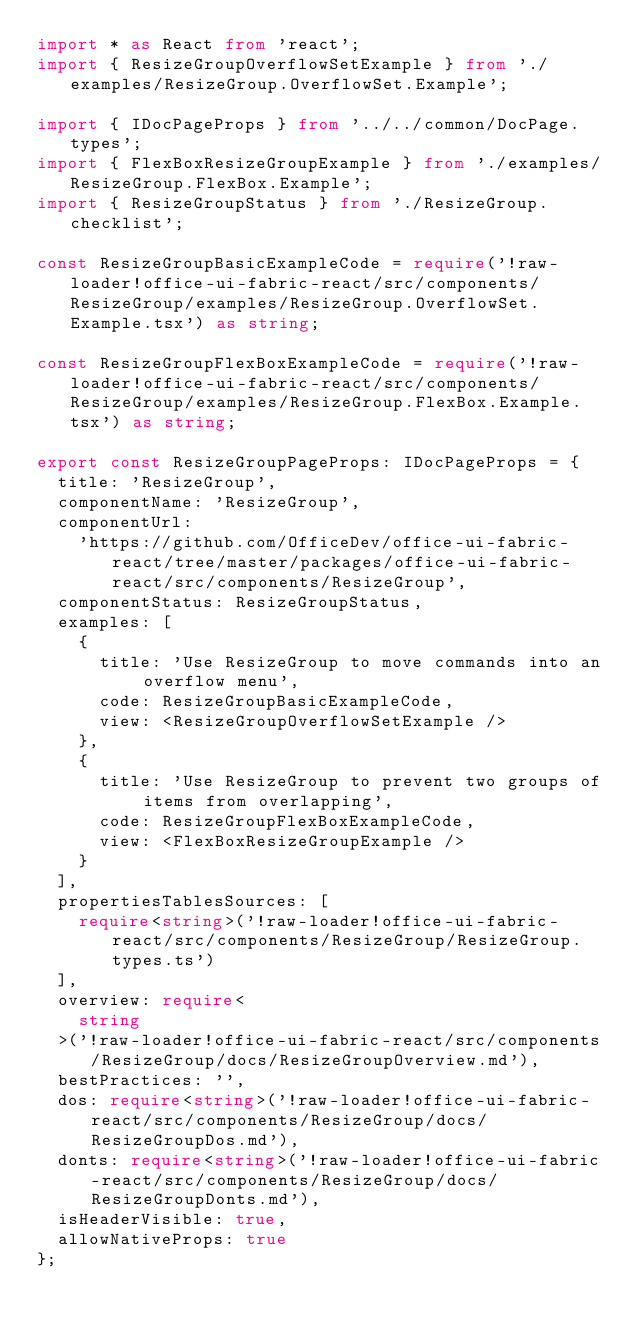<code> <loc_0><loc_0><loc_500><loc_500><_TypeScript_>import * as React from 'react';
import { ResizeGroupOverflowSetExample } from './examples/ResizeGroup.OverflowSet.Example';

import { IDocPageProps } from '../../common/DocPage.types';
import { FlexBoxResizeGroupExample } from './examples/ResizeGroup.FlexBox.Example';
import { ResizeGroupStatus } from './ResizeGroup.checklist';

const ResizeGroupBasicExampleCode = require('!raw-loader!office-ui-fabric-react/src/components/ResizeGroup/examples/ResizeGroup.OverflowSet.Example.tsx') as string;

const ResizeGroupFlexBoxExampleCode = require('!raw-loader!office-ui-fabric-react/src/components/ResizeGroup/examples/ResizeGroup.FlexBox.Example.tsx') as string;

export const ResizeGroupPageProps: IDocPageProps = {
  title: 'ResizeGroup',
  componentName: 'ResizeGroup',
  componentUrl:
    'https://github.com/OfficeDev/office-ui-fabric-react/tree/master/packages/office-ui-fabric-react/src/components/ResizeGroup',
  componentStatus: ResizeGroupStatus,
  examples: [
    {
      title: 'Use ResizeGroup to move commands into an overflow menu',
      code: ResizeGroupBasicExampleCode,
      view: <ResizeGroupOverflowSetExample />
    },
    {
      title: 'Use ResizeGroup to prevent two groups of items from overlapping',
      code: ResizeGroupFlexBoxExampleCode,
      view: <FlexBoxResizeGroupExample />
    }
  ],
  propertiesTablesSources: [
    require<string>('!raw-loader!office-ui-fabric-react/src/components/ResizeGroup/ResizeGroup.types.ts')
  ],
  overview: require<
    string
  >('!raw-loader!office-ui-fabric-react/src/components/ResizeGroup/docs/ResizeGroupOverview.md'),
  bestPractices: '',
  dos: require<string>('!raw-loader!office-ui-fabric-react/src/components/ResizeGroup/docs/ResizeGroupDos.md'),
  donts: require<string>('!raw-loader!office-ui-fabric-react/src/components/ResizeGroup/docs/ResizeGroupDonts.md'),
  isHeaderVisible: true,
  allowNativeProps: true
};
</code> 